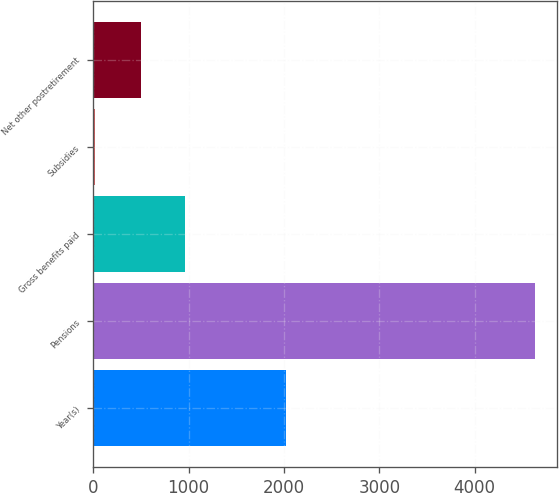<chart> <loc_0><loc_0><loc_500><loc_500><bar_chart><fcel>Year(s)<fcel>Pensions<fcel>Gross benefits paid<fcel>Subsidies<fcel>Net other postretirement<nl><fcel>2022<fcel>4631<fcel>960.4<fcel>17<fcel>499<nl></chart> 